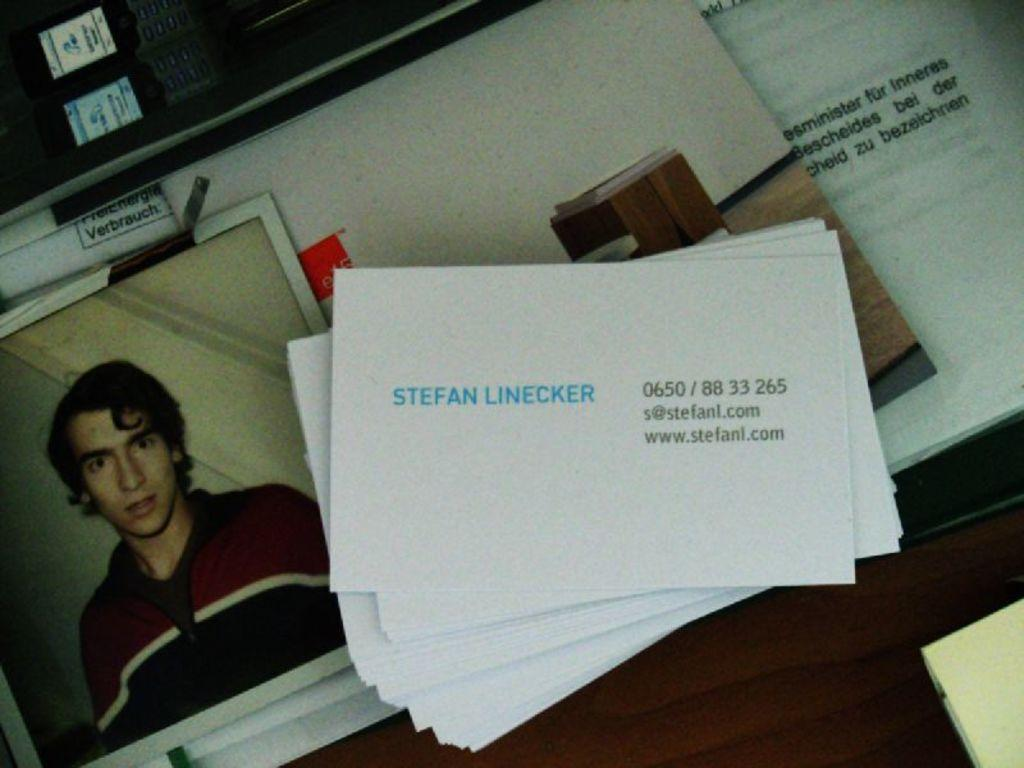<image>
Give a short and clear explanation of the subsequent image. a card with the name Stefan written on it 